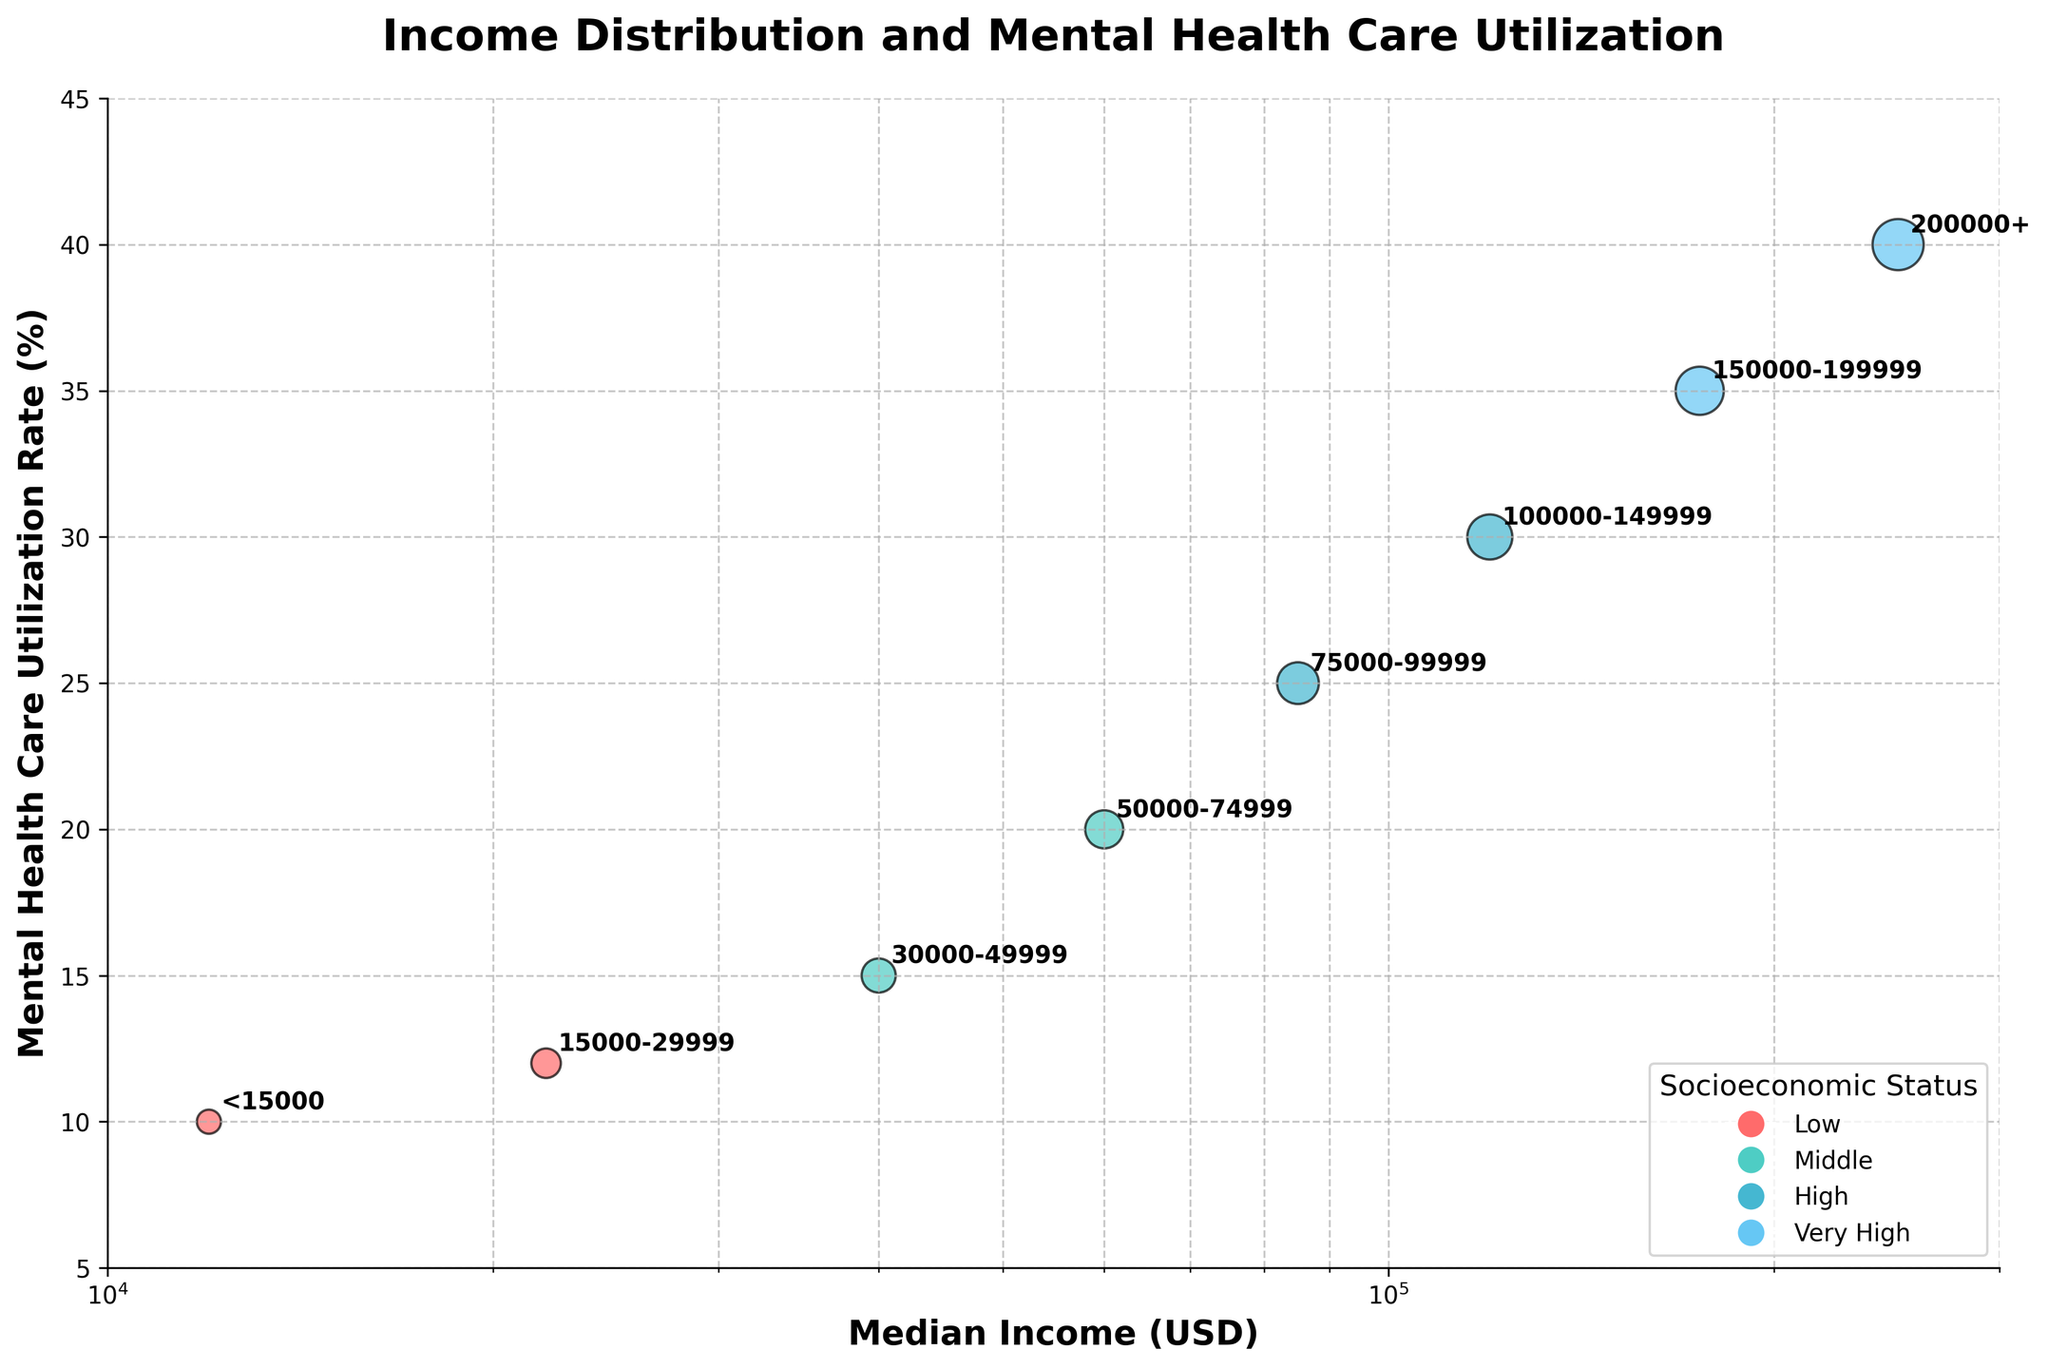Which socioeconomic status category has the highest mental health care utilization rate? The category with the highest mental health care utilization rate can be found by looking at the y-axis values and identifying the highest point. The highest point corresponds to the "Very High" socioeconomic status with a utilization rate of 40%.
Answer: Very High What is the relationship between median income and mental health care utilization rate? By observing the plot, we can see a clear trend where higher median income brackets correspond to higher mental health care utilization rates. This indicates that as income increases, the utilization of mental health care also increases.
Answer: Positive correlation What is the mental health care utilization rate for households with a median income in the $100,000-$149,999 range? Locate the median income bracket $100,000-$149,999 on the x-axis and look up to find the corresponding mental health care utilization rate on the y-axis, which is 30%.
Answer: 30% How does the mental health care utilization rate change from the 'Low' to 'High' socioeconomic status categories? By comparing the mental health care utilization rates for 'Low' (10% and 12%) and 'High' (25% and 30%) socioeconomic status categories, we can observe that the utilization rate increases as the socioeconomic status rises.
Answer: It increases Which median income range has the lowest utilization rate for mental health care, and what is that rate? The median income range with the lowest utilization rate is < $15,000. By looking at the y-axis value corresponding to this income range, we see the rate is 10%.
Answer: < $15,000, 10% Are there any significant jumps in mental health care utilization rates between consecutive income brackets? To find significant jumps, we compare the utilization rates between consecutive income brackets. The jump from $15,000-$29,999 (12%) to $30,000-$49,999 (15%) and from $50,000-$74,999 (20%) to $75,000-$99,999 (25%) are the most notable changes.
Answer: Yes Which two income brackets show the greatest difference in mental health care utilization rates? The greatest difference is found by comparing the highest and lowest utilization rates. < $15,000 has a 10% rate and $200,000+ has a 40% rate, resulting in a difference of 30%.
Answer: < $15,000 and $200,000+, 30% On a log scale, how does the spread of points for income brackets compare to a linear scale? On a log scale, the points are more evenly distributed and spread out along the x-axis, allowing better visualization of differences in median income compared to a linear scale, where higher income brackets would be compressed towards the right side.
Answer: More evenly spread 